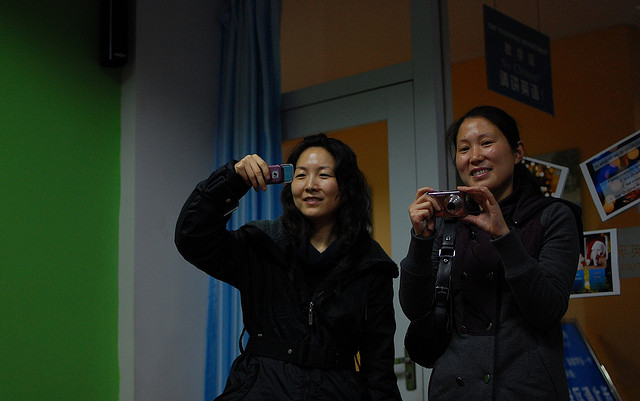<image>What is the woman taking a picture of? It is ambiguous what the woman is taking a picture of. It could be a selfie, a friend, a dog or scenery. What kind of game are they playing? They are not playing any game. It looks like they are taking pictures. What motion are the people making? It is ambiguous what motion the people are making. They could be taking pictures or lifting phones. What is she taking a picture of? I don't know what she is taking a picture of. It could be herself, friends or others. What console are these people playing with? I am not sure what console these people are playing with. It could be Xbox, Sony, or Wii, or they might not be playing with a console at all. What is the woman taking a picture of? The woman is taking a picture of her friend, herself, or the scenery. What kind of game are they playing? It is ambiguous what kind of game they are playing. They are not playing any game mentioned in the answers. What is she taking a picture of? She is taking a picture of herself, her friends, or maybe just the room. What motion are the people making? It is unknown what motion the people are making. It can be seen that they are taking pictures, clicking, and photographing. What console are these people playing with? I don't know what console these people are playing with. It can be Xbox, Sony, Wii or none at all. 